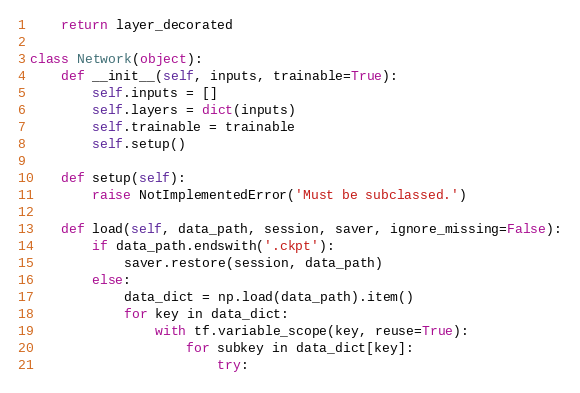<code> <loc_0><loc_0><loc_500><loc_500><_Python_>    return layer_decorated

class Network(object):
    def __init__(self, inputs, trainable=True):
        self.inputs = []
        self.layers = dict(inputs)
        self.trainable = trainable
        self.setup()

    def setup(self):
        raise NotImplementedError('Must be subclassed.')

    def load(self, data_path, session, saver, ignore_missing=False):
        if data_path.endswith('.ckpt'):
            saver.restore(session, data_path)
        else:
            data_dict = np.load(data_path).item()
            for key in data_dict:
                with tf.variable_scope(key, reuse=True):
                    for subkey in data_dict[key]:
                        try:</code> 